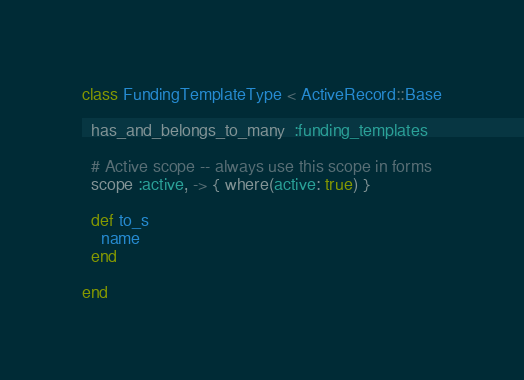Convert code to text. <code><loc_0><loc_0><loc_500><loc_500><_Ruby_>class FundingTemplateType < ActiveRecord::Base

  has_and_belongs_to_many  :funding_templates

  # Active scope -- always use this scope in forms
  scope :active, -> { where(active: true) }

  def to_s
    name
  end

end
</code> 